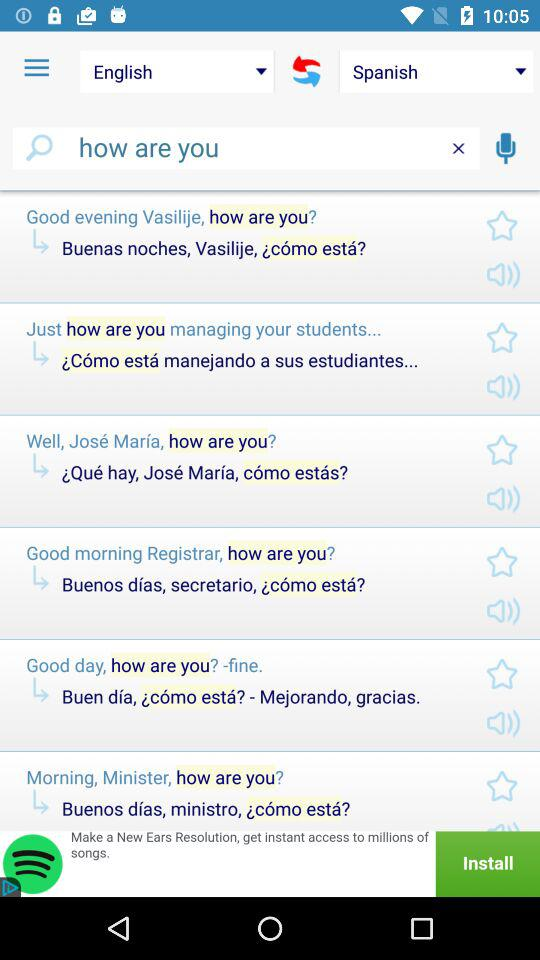Which language is translated into Spanish? The language translated into Spanish is English. 